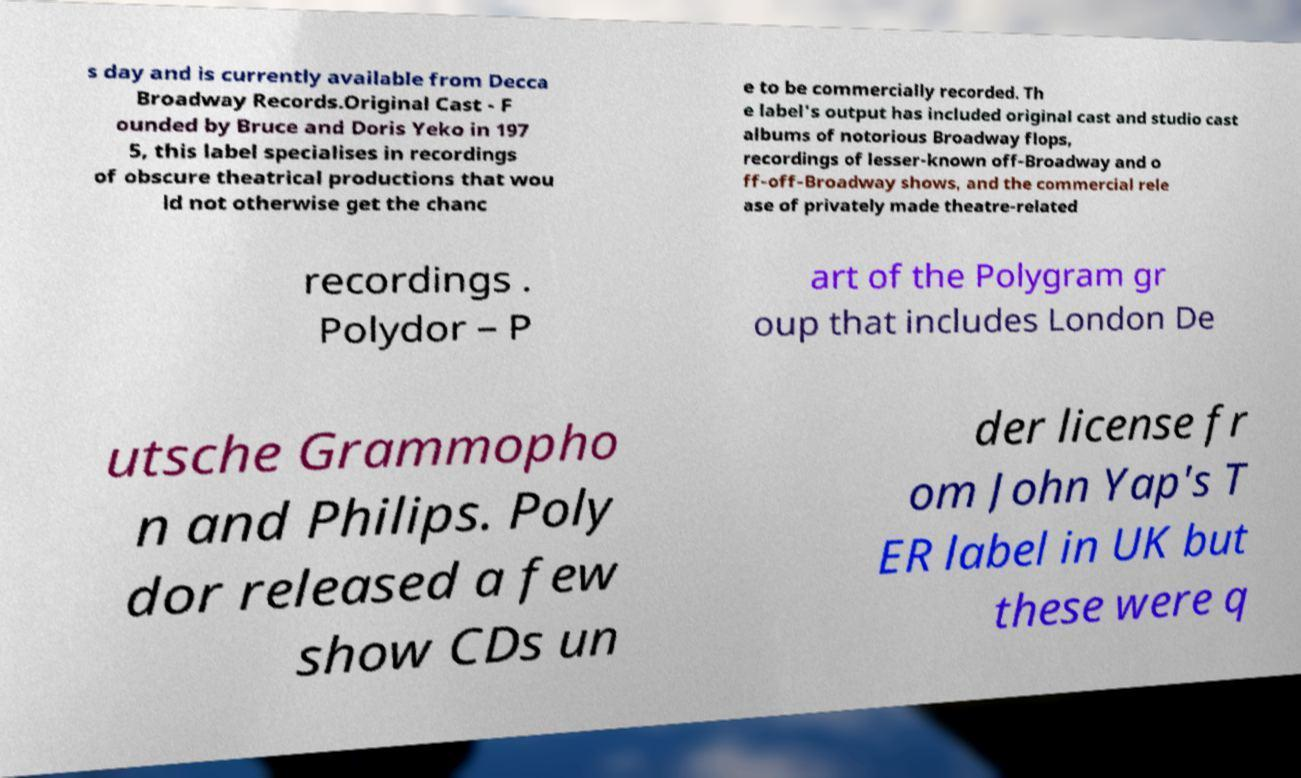For documentation purposes, I need the text within this image transcribed. Could you provide that? s day and is currently available from Decca Broadway Records.Original Cast - F ounded by Bruce and Doris Yeko in 197 5, this label specialises in recordings of obscure theatrical productions that wou ld not otherwise get the chanc e to be commercially recorded. Th e label's output has included original cast and studio cast albums of notorious Broadway flops, recordings of lesser-known off-Broadway and o ff-off-Broadway shows, and the commercial rele ase of privately made theatre-related recordings . Polydor – P art of the Polygram gr oup that includes London De utsche Grammopho n and Philips. Poly dor released a few show CDs un der license fr om John Yap's T ER label in UK but these were q 